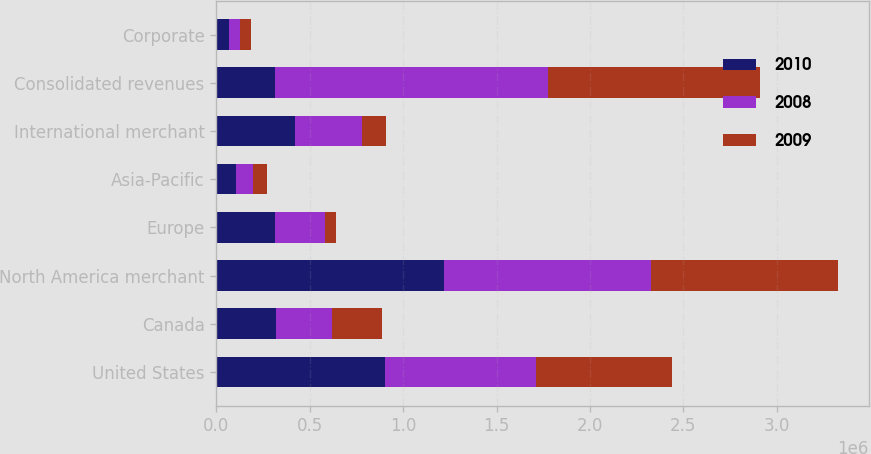<chart> <loc_0><loc_0><loc_500><loc_500><stacked_bar_chart><ecel><fcel>United States<fcel>Canada<fcel>North America merchant<fcel>Europe<fcel>Asia-Pacific<fcel>International merchant<fcel>Consolidated revenues<fcel>Corporate<nl><fcel>2010<fcel>902844<fcel>317272<fcel>1.22012e+06<fcel>315023<fcel>107329<fcel>422352<fcel>315023<fcel>65806<nl><fcel>2008<fcel>805557<fcel>301294<fcel>1.10685e+06<fcel>265121<fcel>90334<fcel>355455<fcel>1.46231e+06<fcel>63189<nl><fcel>2009<fcel>731214<fcel>267249<fcel>998463<fcel>59778<fcel>72367<fcel>132145<fcel>1.13061e+06<fcel>53989<nl></chart> 